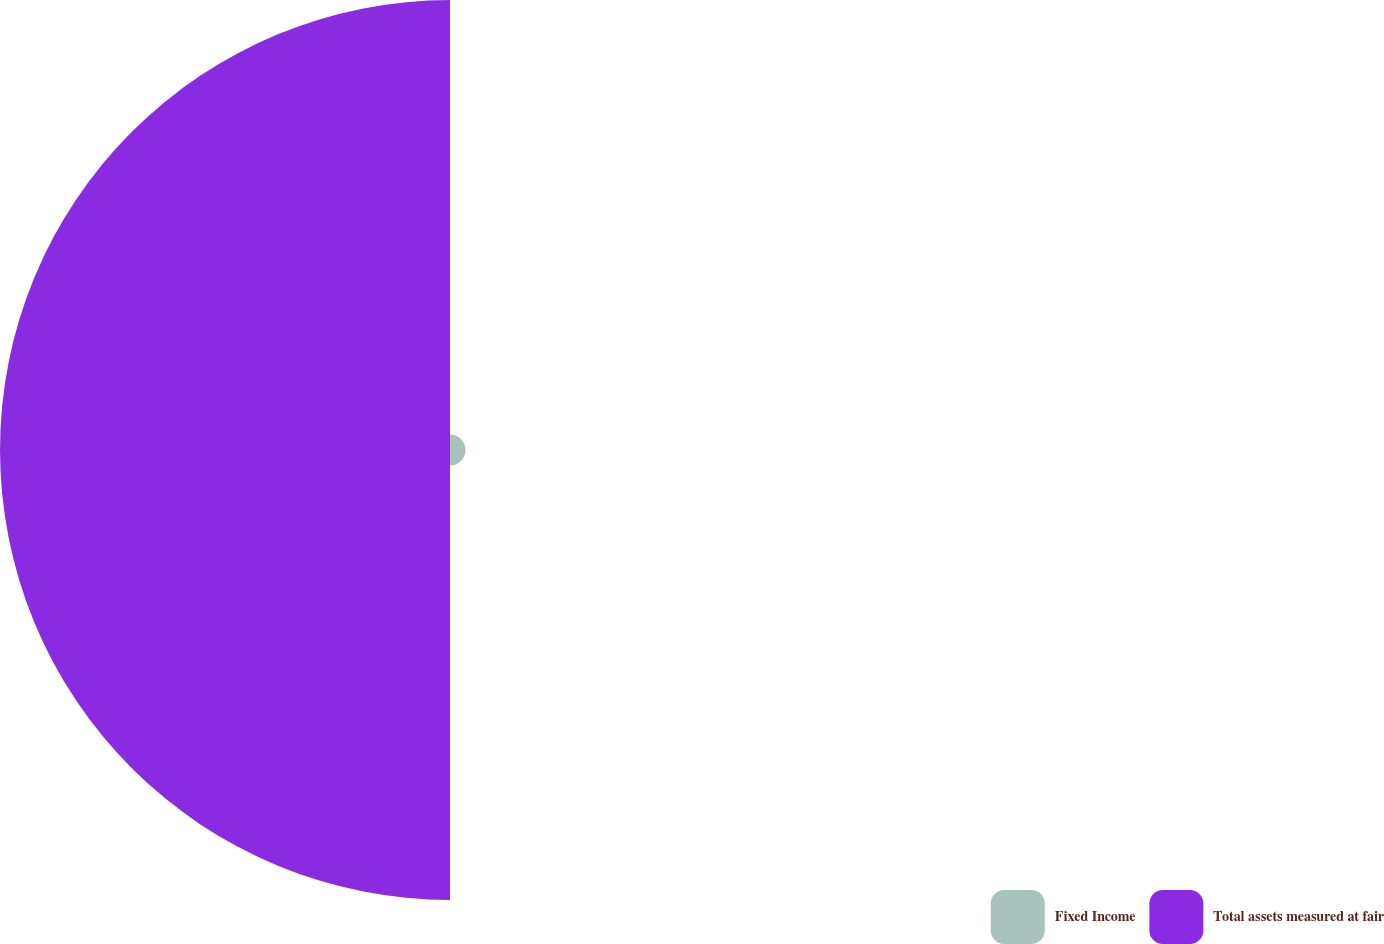<chart> <loc_0><loc_0><loc_500><loc_500><pie_chart><fcel>Fixed Income<fcel>Total assets measured at fair<nl><fcel>3.33%<fcel>96.67%<nl></chart> 